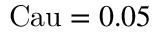<formula> <loc_0><loc_0><loc_500><loc_500>C a u = 0 . 0 5</formula> 